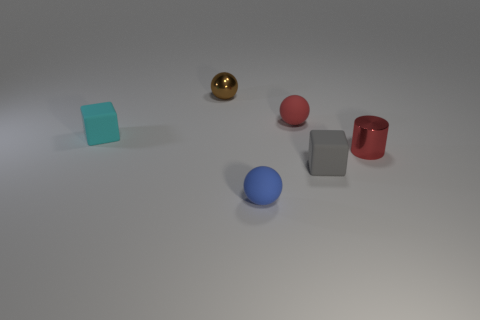Is the material of the small gray block the same as the cyan block?
Make the answer very short. Yes. There is a red object that is behind the small red cylinder; how many tiny rubber cubes are right of it?
Make the answer very short. 1. Is there a purple thing of the same shape as the small blue matte thing?
Your answer should be very brief. No. There is a tiny metallic object that is left of the tiny blue matte object; is it the same shape as the metal object that is in front of the small cyan matte object?
Your response must be concise. No. What is the shape of the small thing that is behind the tiny red metal cylinder and on the right side of the tiny blue thing?
Your answer should be compact. Sphere. Is there a sphere that has the same size as the blue matte object?
Ensure brevity in your answer.  Yes. Is the color of the tiny cylinder the same as the matte object behind the tiny cyan object?
Your response must be concise. Yes. What is the material of the brown thing?
Give a very brief answer. Metal. The rubber sphere in front of the tiny cylinder is what color?
Provide a short and direct response. Blue. How many big matte objects are the same color as the metal cylinder?
Provide a succinct answer. 0. 